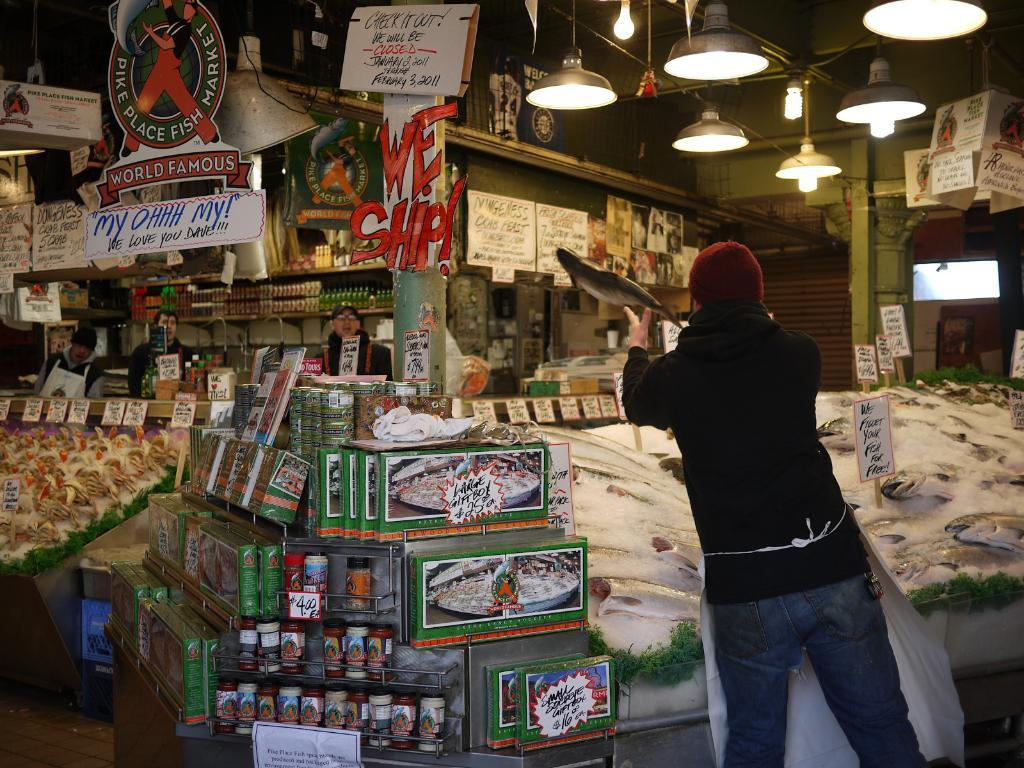<image>
Relay a brief, clear account of the picture shown. A man is in the Pike Place Fish Market catching a fish thrown to him. 